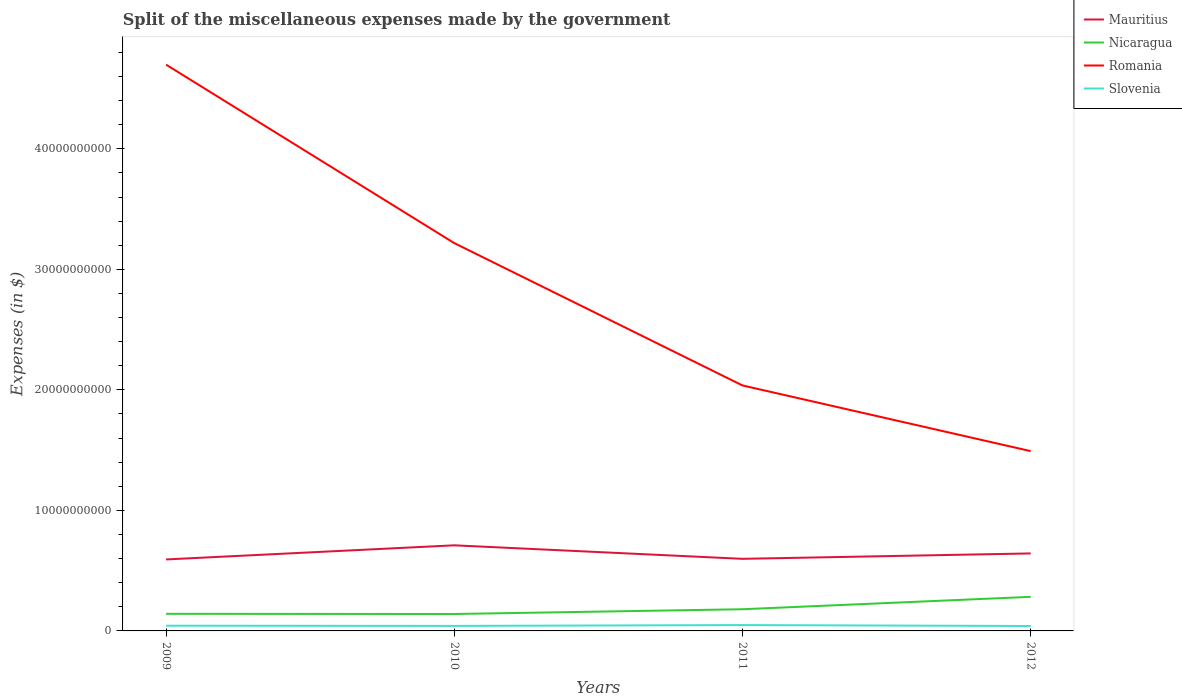How many different coloured lines are there?
Provide a short and direct response. 4. Across all years, what is the maximum miscellaneous expenses made by the government in Mauritius?
Provide a short and direct response. 5.93e+09. What is the total miscellaneous expenses made by the government in Mauritius in the graph?
Your answer should be compact. 1.12e+09. What is the difference between the highest and the second highest miscellaneous expenses made by the government in Nicaragua?
Keep it short and to the point. 1.42e+09. Is the miscellaneous expenses made by the government in Slovenia strictly greater than the miscellaneous expenses made by the government in Mauritius over the years?
Your answer should be very brief. Yes. How many years are there in the graph?
Your answer should be very brief. 4. What is the difference between two consecutive major ticks on the Y-axis?
Offer a very short reply. 1.00e+1. Are the values on the major ticks of Y-axis written in scientific E-notation?
Offer a terse response. No. Does the graph contain any zero values?
Provide a short and direct response. No. Does the graph contain grids?
Provide a succinct answer. No. How many legend labels are there?
Give a very brief answer. 4. What is the title of the graph?
Provide a succinct answer. Split of the miscellaneous expenses made by the government. Does "Ireland" appear as one of the legend labels in the graph?
Offer a very short reply. No. What is the label or title of the Y-axis?
Ensure brevity in your answer.  Expenses (in $). What is the Expenses (in $) in Mauritius in 2009?
Make the answer very short. 5.93e+09. What is the Expenses (in $) in Nicaragua in 2009?
Your response must be concise. 1.42e+09. What is the Expenses (in $) of Romania in 2009?
Offer a terse response. 4.70e+1. What is the Expenses (in $) in Slovenia in 2009?
Your response must be concise. 4.33e+08. What is the Expenses (in $) of Mauritius in 2010?
Your answer should be compact. 7.10e+09. What is the Expenses (in $) of Nicaragua in 2010?
Ensure brevity in your answer.  1.40e+09. What is the Expenses (in $) of Romania in 2010?
Offer a very short reply. 3.22e+1. What is the Expenses (in $) in Slovenia in 2010?
Your response must be concise. 4.17e+08. What is the Expenses (in $) in Mauritius in 2011?
Give a very brief answer. 5.98e+09. What is the Expenses (in $) in Nicaragua in 2011?
Make the answer very short. 1.80e+09. What is the Expenses (in $) of Romania in 2011?
Your answer should be compact. 2.04e+1. What is the Expenses (in $) in Slovenia in 2011?
Your response must be concise. 4.86e+08. What is the Expenses (in $) in Mauritius in 2012?
Keep it short and to the point. 6.43e+09. What is the Expenses (in $) in Nicaragua in 2012?
Your answer should be compact. 2.83e+09. What is the Expenses (in $) in Romania in 2012?
Provide a short and direct response. 1.49e+1. What is the Expenses (in $) of Slovenia in 2012?
Keep it short and to the point. 4.08e+08. Across all years, what is the maximum Expenses (in $) in Mauritius?
Offer a terse response. 7.10e+09. Across all years, what is the maximum Expenses (in $) in Nicaragua?
Keep it short and to the point. 2.83e+09. Across all years, what is the maximum Expenses (in $) of Romania?
Make the answer very short. 4.70e+1. Across all years, what is the maximum Expenses (in $) in Slovenia?
Make the answer very short. 4.86e+08. Across all years, what is the minimum Expenses (in $) of Mauritius?
Give a very brief answer. 5.93e+09. Across all years, what is the minimum Expenses (in $) of Nicaragua?
Your answer should be compact. 1.40e+09. Across all years, what is the minimum Expenses (in $) in Romania?
Ensure brevity in your answer.  1.49e+1. Across all years, what is the minimum Expenses (in $) in Slovenia?
Keep it short and to the point. 4.08e+08. What is the total Expenses (in $) in Mauritius in the graph?
Provide a short and direct response. 2.54e+1. What is the total Expenses (in $) of Nicaragua in the graph?
Ensure brevity in your answer.  7.45e+09. What is the total Expenses (in $) of Romania in the graph?
Give a very brief answer. 1.14e+11. What is the total Expenses (in $) in Slovenia in the graph?
Offer a very short reply. 1.74e+09. What is the difference between the Expenses (in $) in Mauritius in 2009 and that in 2010?
Ensure brevity in your answer.  -1.17e+09. What is the difference between the Expenses (in $) of Nicaragua in 2009 and that in 2010?
Your answer should be compact. 1.63e+07. What is the difference between the Expenses (in $) in Romania in 2009 and that in 2010?
Offer a very short reply. 1.48e+1. What is the difference between the Expenses (in $) of Slovenia in 2009 and that in 2010?
Give a very brief answer. 1.65e+07. What is the difference between the Expenses (in $) of Mauritius in 2009 and that in 2011?
Offer a very short reply. -4.98e+07. What is the difference between the Expenses (in $) of Nicaragua in 2009 and that in 2011?
Give a very brief answer. -3.80e+08. What is the difference between the Expenses (in $) of Romania in 2009 and that in 2011?
Keep it short and to the point. 2.66e+1. What is the difference between the Expenses (in $) of Slovenia in 2009 and that in 2011?
Give a very brief answer. -5.26e+07. What is the difference between the Expenses (in $) of Mauritius in 2009 and that in 2012?
Your answer should be compact. -4.99e+08. What is the difference between the Expenses (in $) of Nicaragua in 2009 and that in 2012?
Provide a short and direct response. -1.41e+09. What is the difference between the Expenses (in $) of Romania in 2009 and that in 2012?
Offer a very short reply. 3.21e+1. What is the difference between the Expenses (in $) of Slovenia in 2009 and that in 2012?
Your response must be concise. 2.51e+07. What is the difference between the Expenses (in $) of Mauritius in 2010 and that in 2011?
Provide a succinct answer. 1.12e+09. What is the difference between the Expenses (in $) in Nicaragua in 2010 and that in 2011?
Offer a very short reply. -3.96e+08. What is the difference between the Expenses (in $) of Romania in 2010 and that in 2011?
Your answer should be compact. 1.18e+1. What is the difference between the Expenses (in $) in Slovenia in 2010 and that in 2011?
Provide a short and direct response. -6.92e+07. What is the difference between the Expenses (in $) of Mauritius in 2010 and that in 2012?
Offer a terse response. 6.73e+08. What is the difference between the Expenses (in $) in Nicaragua in 2010 and that in 2012?
Your answer should be very brief. -1.42e+09. What is the difference between the Expenses (in $) of Romania in 2010 and that in 2012?
Your answer should be very brief. 1.73e+1. What is the difference between the Expenses (in $) in Slovenia in 2010 and that in 2012?
Provide a short and direct response. 8.61e+06. What is the difference between the Expenses (in $) in Mauritius in 2011 and that in 2012?
Keep it short and to the point. -4.49e+08. What is the difference between the Expenses (in $) in Nicaragua in 2011 and that in 2012?
Offer a very short reply. -1.03e+09. What is the difference between the Expenses (in $) of Romania in 2011 and that in 2012?
Ensure brevity in your answer.  5.45e+09. What is the difference between the Expenses (in $) in Slovenia in 2011 and that in 2012?
Your answer should be very brief. 7.78e+07. What is the difference between the Expenses (in $) of Mauritius in 2009 and the Expenses (in $) of Nicaragua in 2010?
Your response must be concise. 4.53e+09. What is the difference between the Expenses (in $) of Mauritius in 2009 and the Expenses (in $) of Romania in 2010?
Offer a very short reply. -2.62e+1. What is the difference between the Expenses (in $) in Mauritius in 2009 and the Expenses (in $) in Slovenia in 2010?
Give a very brief answer. 5.51e+09. What is the difference between the Expenses (in $) of Nicaragua in 2009 and the Expenses (in $) of Romania in 2010?
Provide a succinct answer. -3.08e+1. What is the difference between the Expenses (in $) in Nicaragua in 2009 and the Expenses (in $) in Slovenia in 2010?
Provide a short and direct response. 1.00e+09. What is the difference between the Expenses (in $) in Romania in 2009 and the Expenses (in $) in Slovenia in 2010?
Your response must be concise. 4.66e+1. What is the difference between the Expenses (in $) in Mauritius in 2009 and the Expenses (in $) in Nicaragua in 2011?
Provide a short and direct response. 4.13e+09. What is the difference between the Expenses (in $) of Mauritius in 2009 and the Expenses (in $) of Romania in 2011?
Your response must be concise. -1.44e+1. What is the difference between the Expenses (in $) in Mauritius in 2009 and the Expenses (in $) in Slovenia in 2011?
Keep it short and to the point. 5.45e+09. What is the difference between the Expenses (in $) of Nicaragua in 2009 and the Expenses (in $) of Romania in 2011?
Your response must be concise. -1.89e+1. What is the difference between the Expenses (in $) in Nicaragua in 2009 and the Expenses (in $) in Slovenia in 2011?
Your answer should be compact. 9.34e+08. What is the difference between the Expenses (in $) of Romania in 2009 and the Expenses (in $) of Slovenia in 2011?
Provide a short and direct response. 4.65e+1. What is the difference between the Expenses (in $) in Mauritius in 2009 and the Expenses (in $) in Nicaragua in 2012?
Offer a very short reply. 3.10e+09. What is the difference between the Expenses (in $) of Mauritius in 2009 and the Expenses (in $) of Romania in 2012?
Your answer should be very brief. -8.99e+09. What is the difference between the Expenses (in $) of Mauritius in 2009 and the Expenses (in $) of Slovenia in 2012?
Ensure brevity in your answer.  5.52e+09. What is the difference between the Expenses (in $) in Nicaragua in 2009 and the Expenses (in $) in Romania in 2012?
Provide a short and direct response. -1.35e+1. What is the difference between the Expenses (in $) in Nicaragua in 2009 and the Expenses (in $) in Slovenia in 2012?
Offer a very short reply. 1.01e+09. What is the difference between the Expenses (in $) of Romania in 2009 and the Expenses (in $) of Slovenia in 2012?
Your response must be concise. 4.66e+1. What is the difference between the Expenses (in $) of Mauritius in 2010 and the Expenses (in $) of Nicaragua in 2011?
Provide a succinct answer. 5.30e+09. What is the difference between the Expenses (in $) of Mauritius in 2010 and the Expenses (in $) of Romania in 2011?
Provide a succinct answer. -1.33e+1. What is the difference between the Expenses (in $) of Mauritius in 2010 and the Expenses (in $) of Slovenia in 2011?
Provide a short and direct response. 6.62e+09. What is the difference between the Expenses (in $) of Nicaragua in 2010 and the Expenses (in $) of Romania in 2011?
Offer a very short reply. -1.90e+1. What is the difference between the Expenses (in $) in Nicaragua in 2010 and the Expenses (in $) in Slovenia in 2011?
Ensure brevity in your answer.  9.17e+08. What is the difference between the Expenses (in $) of Romania in 2010 and the Expenses (in $) of Slovenia in 2011?
Provide a succinct answer. 3.17e+1. What is the difference between the Expenses (in $) of Mauritius in 2010 and the Expenses (in $) of Nicaragua in 2012?
Offer a very short reply. 4.28e+09. What is the difference between the Expenses (in $) of Mauritius in 2010 and the Expenses (in $) of Romania in 2012?
Ensure brevity in your answer.  -7.81e+09. What is the difference between the Expenses (in $) in Mauritius in 2010 and the Expenses (in $) in Slovenia in 2012?
Provide a succinct answer. 6.69e+09. What is the difference between the Expenses (in $) of Nicaragua in 2010 and the Expenses (in $) of Romania in 2012?
Your answer should be compact. -1.35e+1. What is the difference between the Expenses (in $) of Nicaragua in 2010 and the Expenses (in $) of Slovenia in 2012?
Ensure brevity in your answer.  9.95e+08. What is the difference between the Expenses (in $) of Romania in 2010 and the Expenses (in $) of Slovenia in 2012?
Provide a succinct answer. 3.18e+1. What is the difference between the Expenses (in $) in Mauritius in 2011 and the Expenses (in $) in Nicaragua in 2012?
Your response must be concise. 3.15e+09. What is the difference between the Expenses (in $) of Mauritius in 2011 and the Expenses (in $) of Romania in 2012?
Give a very brief answer. -8.94e+09. What is the difference between the Expenses (in $) in Mauritius in 2011 and the Expenses (in $) in Slovenia in 2012?
Provide a short and direct response. 5.57e+09. What is the difference between the Expenses (in $) of Nicaragua in 2011 and the Expenses (in $) of Romania in 2012?
Your answer should be very brief. -1.31e+1. What is the difference between the Expenses (in $) of Nicaragua in 2011 and the Expenses (in $) of Slovenia in 2012?
Ensure brevity in your answer.  1.39e+09. What is the difference between the Expenses (in $) of Romania in 2011 and the Expenses (in $) of Slovenia in 2012?
Ensure brevity in your answer.  2.00e+1. What is the average Expenses (in $) in Mauritius per year?
Ensure brevity in your answer.  6.36e+09. What is the average Expenses (in $) in Nicaragua per year?
Your answer should be compact. 1.86e+09. What is the average Expenses (in $) of Romania per year?
Offer a terse response. 2.86e+1. What is the average Expenses (in $) in Slovenia per year?
Offer a terse response. 4.36e+08. In the year 2009, what is the difference between the Expenses (in $) in Mauritius and Expenses (in $) in Nicaragua?
Give a very brief answer. 4.51e+09. In the year 2009, what is the difference between the Expenses (in $) in Mauritius and Expenses (in $) in Romania?
Give a very brief answer. -4.11e+1. In the year 2009, what is the difference between the Expenses (in $) of Mauritius and Expenses (in $) of Slovenia?
Your answer should be very brief. 5.50e+09. In the year 2009, what is the difference between the Expenses (in $) of Nicaragua and Expenses (in $) of Romania?
Your response must be concise. -4.56e+1. In the year 2009, what is the difference between the Expenses (in $) of Nicaragua and Expenses (in $) of Slovenia?
Offer a terse response. 9.86e+08. In the year 2009, what is the difference between the Expenses (in $) of Romania and Expenses (in $) of Slovenia?
Provide a succinct answer. 4.65e+1. In the year 2010, what is the difference between the Expenses (in $) in Mauritius and Expenses (in $) in Nicaragua?
Keep it short and to the point. 5.70e+09. In the year 2010, what is the difference between the Expenses (in $) of Mauritius and Expenses (in $) of Romania?
Ensure brevity in your answer.  -2.51e+1. In the year 2010, what is the difference between the Expenses (in $) in Mauritius and Expenses (in $) in Slovenia?
Provide a short and direct response. 6.69e+09. In the year 2010, what is the difference between the Expenses (in $) in Nicaragua and Expenses (in $) in Romania?
Keep it short and to the point. -3.08e+1. In the year 2010, what is the difference between the Expenses (in $) of Nicaragua and Expenses (in $) of Slovenia?
Your response must be concise. 9.87e+08. In the year 2010, what is the difference between the Expenses (in $) in Romania and Expenses (in $) in Slovenia?
Keep it short and to the point. 3.18e+1. In the year 2011, what is the difference between the Expenses (in $) in Mauritius and Expenses (in $) in Nicaragua?
Offer a terse response. 4.18e+09. In the year 2011, what is the difference between the Expenses (in $) of Mauritius and Expenses (in $) of Romania?
Offer a very short reply. -1.44e+1. In the year 2011, what is the difference between the Expenses (in $) of Mauritius and Expenses (in $) of Slovenia?
Your answer should be very brief. 5.50e+09. In the year 2011, what is the difference between the Expenses (in $) in Nicaragua and Expenses (in $) in Romania?
Provide a short and direct response. -1.86e+1. In the year 2011, what is the difference between the Expenses (in $) in Nicaragua and Expenses (in $) in Slovenia?
Provide a succinct answer. 1.31e+09. In the year 2011, what is the difference between the Expenses (in $) in Romania and Expenses (in $) in Slovenia?
Provide a short and direct response. 1.99e+1. In the year 2012, what is the difference between the Expenses (in $) of Mauritius and Expenses (in $) of Nicaragua?
Ensure brevity in your answer.  3.60e+09. In the year 2012, what is the difference between the Expenses (in $) in Mauritius and Expenses (in $) in Romania?
Keep it short and to the point. -8.49e+09. In the year 2012, what is the difference between the Expenses (in $) of Mauritius and Expenses (in $) of Slovenia?
Keep it short and to the point. 6.02e+09. In the year 2012, what is the difference between the Expenses (in $) of Nicaragua and Expenses (in $) of Romania?
Provide a succinct answer. -1.21e+1. In the year 2012, what is the difference between the Expenses (in $) of Nicaragua and Expenses (in $) of Slovenia?
Ensure brevity in your answer.  2.42e+09. In the year 2012, what is the difference between the Expenses (in $) of Romania and Expenses (in $) of Slovenia?
Provide a short and direct response. 1.45e+1. What is the ratio of the Expenses (in $) of Mauritius in 2009 to that in 2010?
Offer a terse response. 0.83. What is the ratio of the Expenses (in $) in Nicaragua in 2009 to that in 2010?
Provide a short and direct response. 1.01. What is the ratio of the Expenses (in $) in Romania in 2009 to that in 2010?
Ensure brevity in your answer.  1.46. What is the ratio of the Expenses (in $) in Slovenia in 2009 to that in 2010?
Offer a very short reply. 1.04. What is the ratio of the Expenses (in $) of Mauritius in 2009 to that in 2011?
Give a very brief answer. 0.99. What is the ratio of the Expenses (in $) of Nicaragua in 2009 to that in 2011?
Your answer should be very brief. 0.79. What is the ratio of the Expenses (in $) in Romania in 2009 to that in 2011?
Your response must be concise. 2.31. What is the ratio of the Expenses (in $) in Slovenia in 2009 to that in 2011?
Offer a very short reply. 0.89. What is the ratio of the Expenses (in $) of Mauritius in 2009 to that in 2012?
Your answer should be compact. 0.92. What is the ratio of the Expenses (in $) in Nicaragua in 2009 to that in 2012?
Your answer should be very brief. 0.5. What is the ratio of the Expenses (in $) of Romania in 2009 to that in 2012?
Your response must be concise. 3.15. What is the ratio of the Expenses (in $) in Slovenia in 2009 to that in 2012?
Make the answer very short. 1.06. What is the ratio of the Expenses (in $) of Mauritius in 2010 to that in 2011?
Your response must be concise. 1.19. What is the ratio of the Expenses (in $) in Nicaragua in 2010 to that in 2011?
Give a very brief answer. 0.78. What is the ratio of the Expenses (in $) in Romania in 2010 to that in 2011?
Ensure brevity in your answer.  1.58. What is the ratio of the Expenses (in $) in Slovenia in 2010 to that in 2011?
Offer a terse response. 0.86. What is the ratio of the Expenses (in $) in Mauritius in 2010 to that in 2012?
Offer a very short reply. 1.1. What is the ratio of the Expenses (in $) in Nicaragua in 2010 to that in 2012?
Keep it short and to the point. 0.5. What is the ratio of the Expenses (in $) in Romania in 2010 to that in 2012?
Provide a short and direct response. 2.16. What is the ratio of the Expenses (in $) of Slovenia in 2010 to that in 2012?
Your answer should be compact. 1.02. What is the ratio of the Expenses (in $) of Mauritius in 2011 to that in 2012?
Provide a succinct answer. 0.93. What is the ratio of the Expenses (in $) of Nicaragua in 2011 to that in 2012?
Your answer should be compact. 0.64. What is the ratio of the Expenses (in $) of Romania in 2011 to that in 2012?
Your answer should be very brief. 1.37. What is the ratio of the Expenses (in $) of Slovenia in 2011 to that in 2012?
Your answer should be compact. 1.19. What is the difference between the highest and the second highest Expenses (in $) in Mauritius?
Your answer should be very brief. 6.73e+08. What is the difference between the highest and the second highest Expenses (in $) in Nicaragua?
Make the answer very short. 1.03e+09. What is the difference between the highest and the second highest Expenses (in $) in Romania?
Offer a terse response. 1.48e+1. What is the difference between the highest and the second highest Expenses (in $) in Slovenia?
Your answer should be compact. 5.26e+07. What is the difference between the highest and the lowest Expenses (in $) of Mauritius?
Ensure brevity in your answer.  1.17e+09. What is the difference between the highest and the lowest Expenses (in $) of Nicaragua?
Your response must be concise. 1.42e+09. What is the difference between the highest and the lowest Expenses (in $) of Romania?
Your response must be concise. 3.21e+1. What is the difference between the highest and the lowest Expenses (in $) of Slovenia?
Your response must be concise. 7.78e+07. 